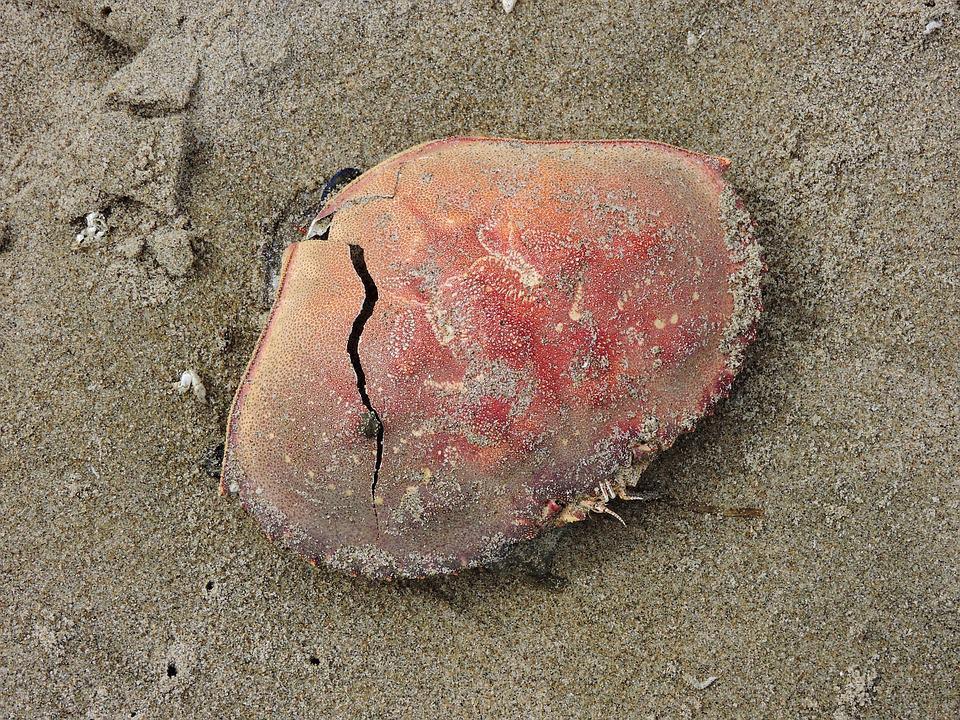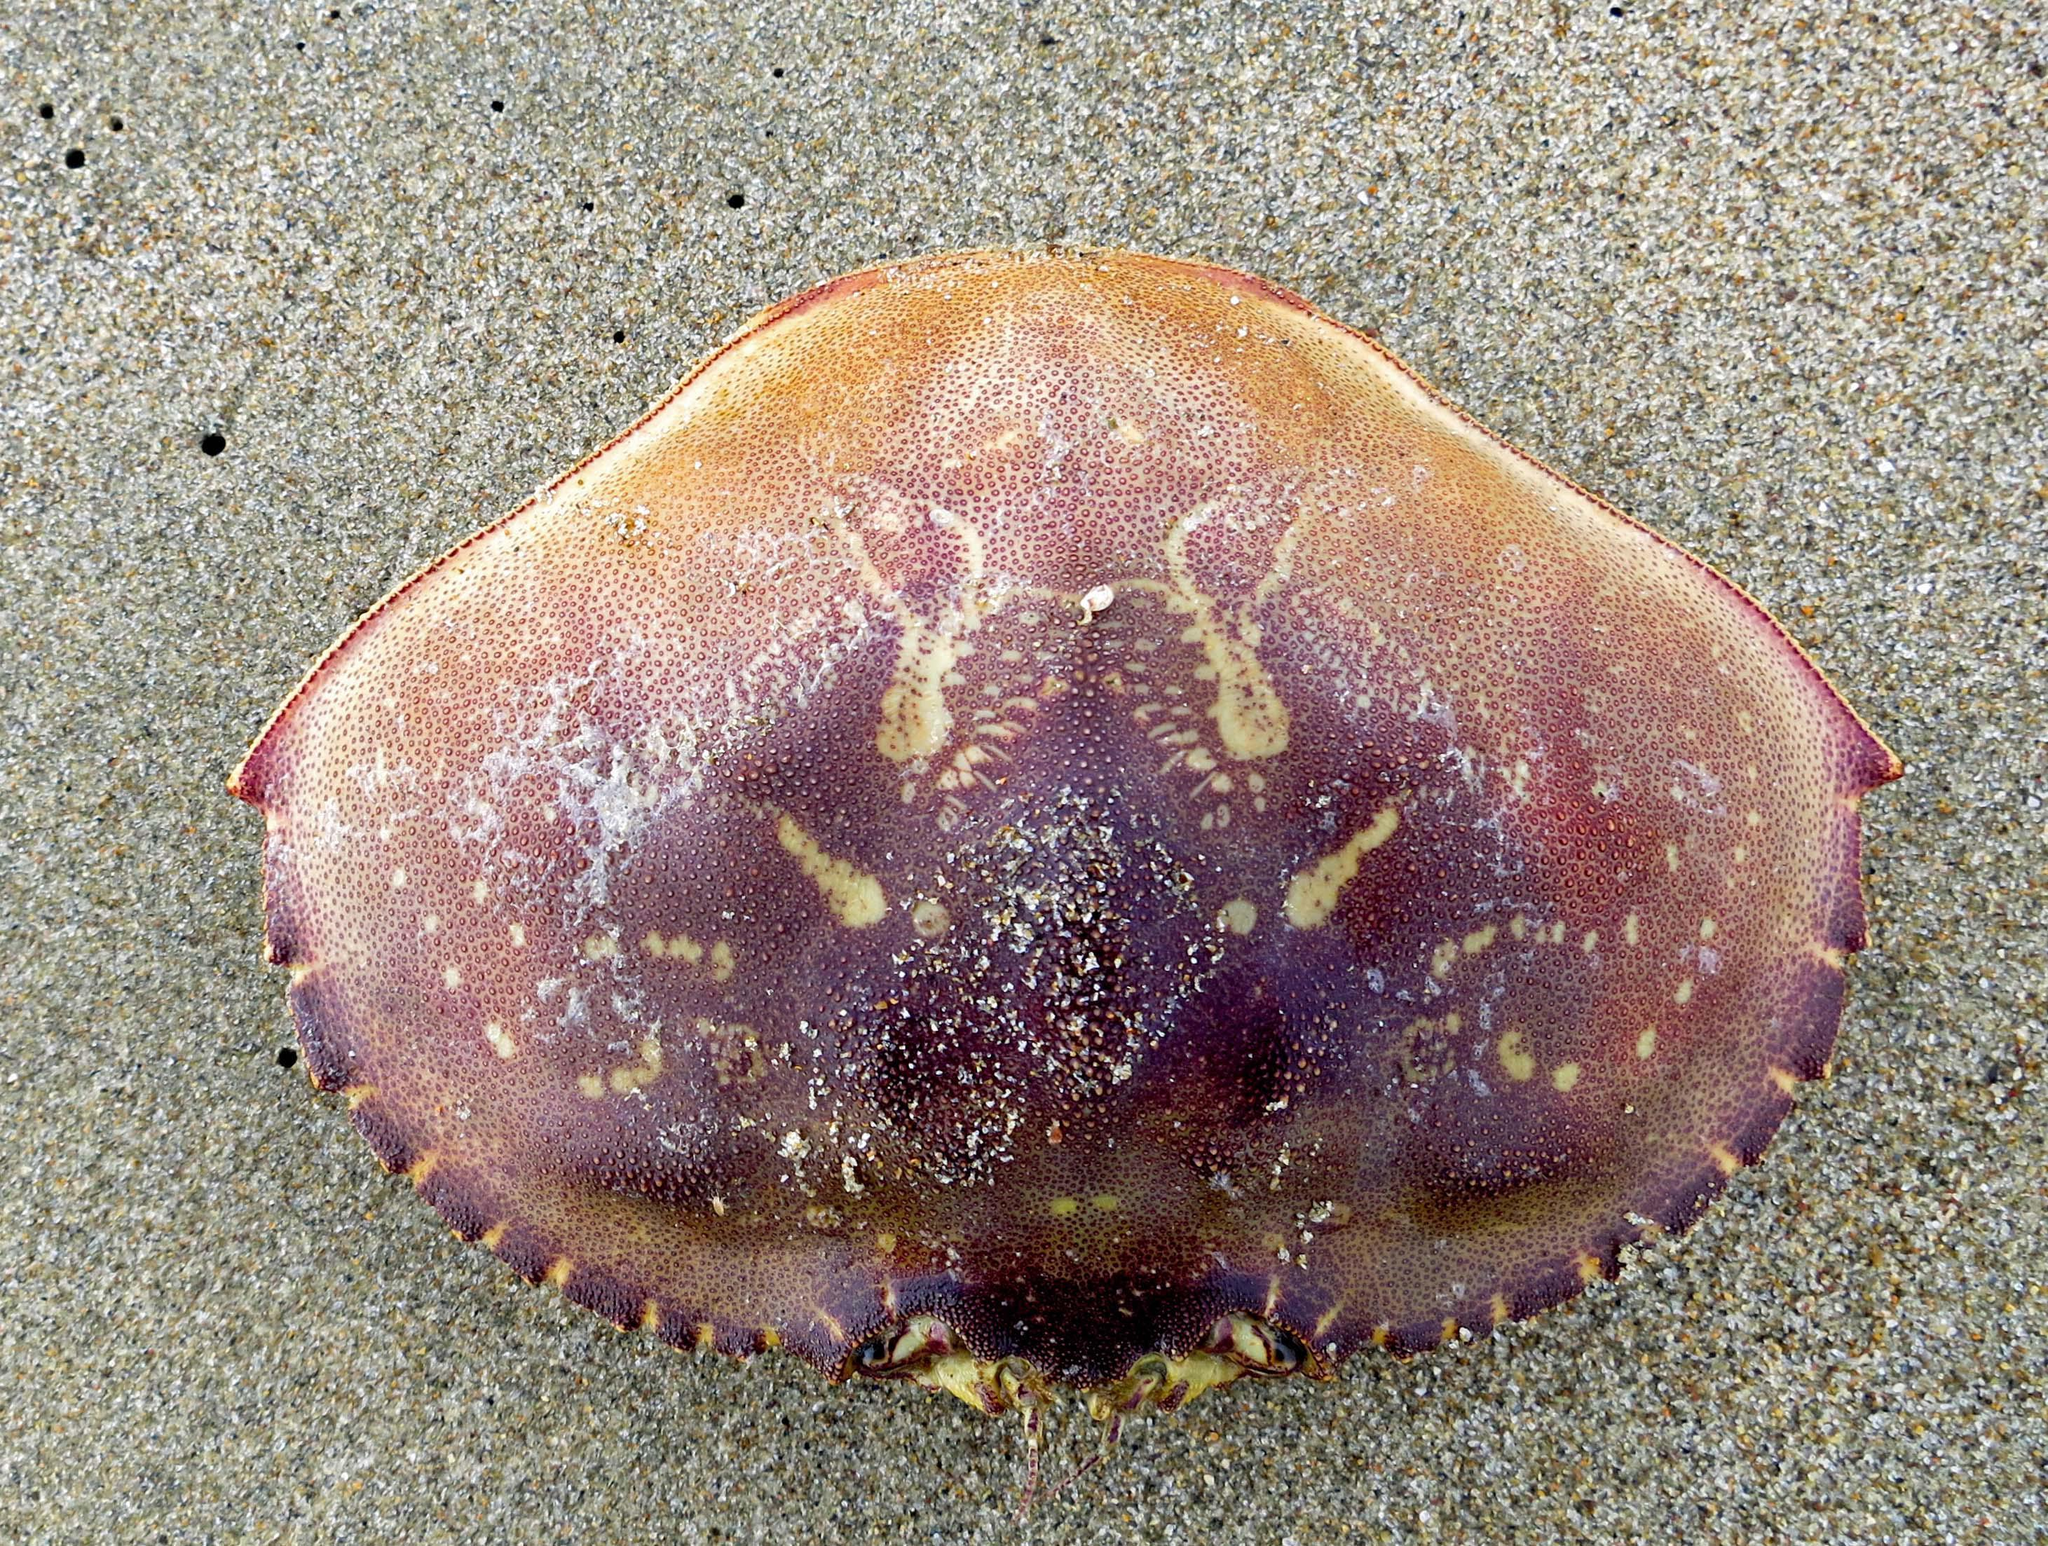The first image is the image on the left, the second image is the image on the right. Examine the images to the left and right. Is the description "there are two crab sheels on the sand in the image pair" accurate? Answer yes or no. Yes. The first image is the image on the left, the second image is the image on the right. Examine the images to the left and right. Is the description "Each crab sits on a sandy surface." accurate? Answer yes or no. Yes. 